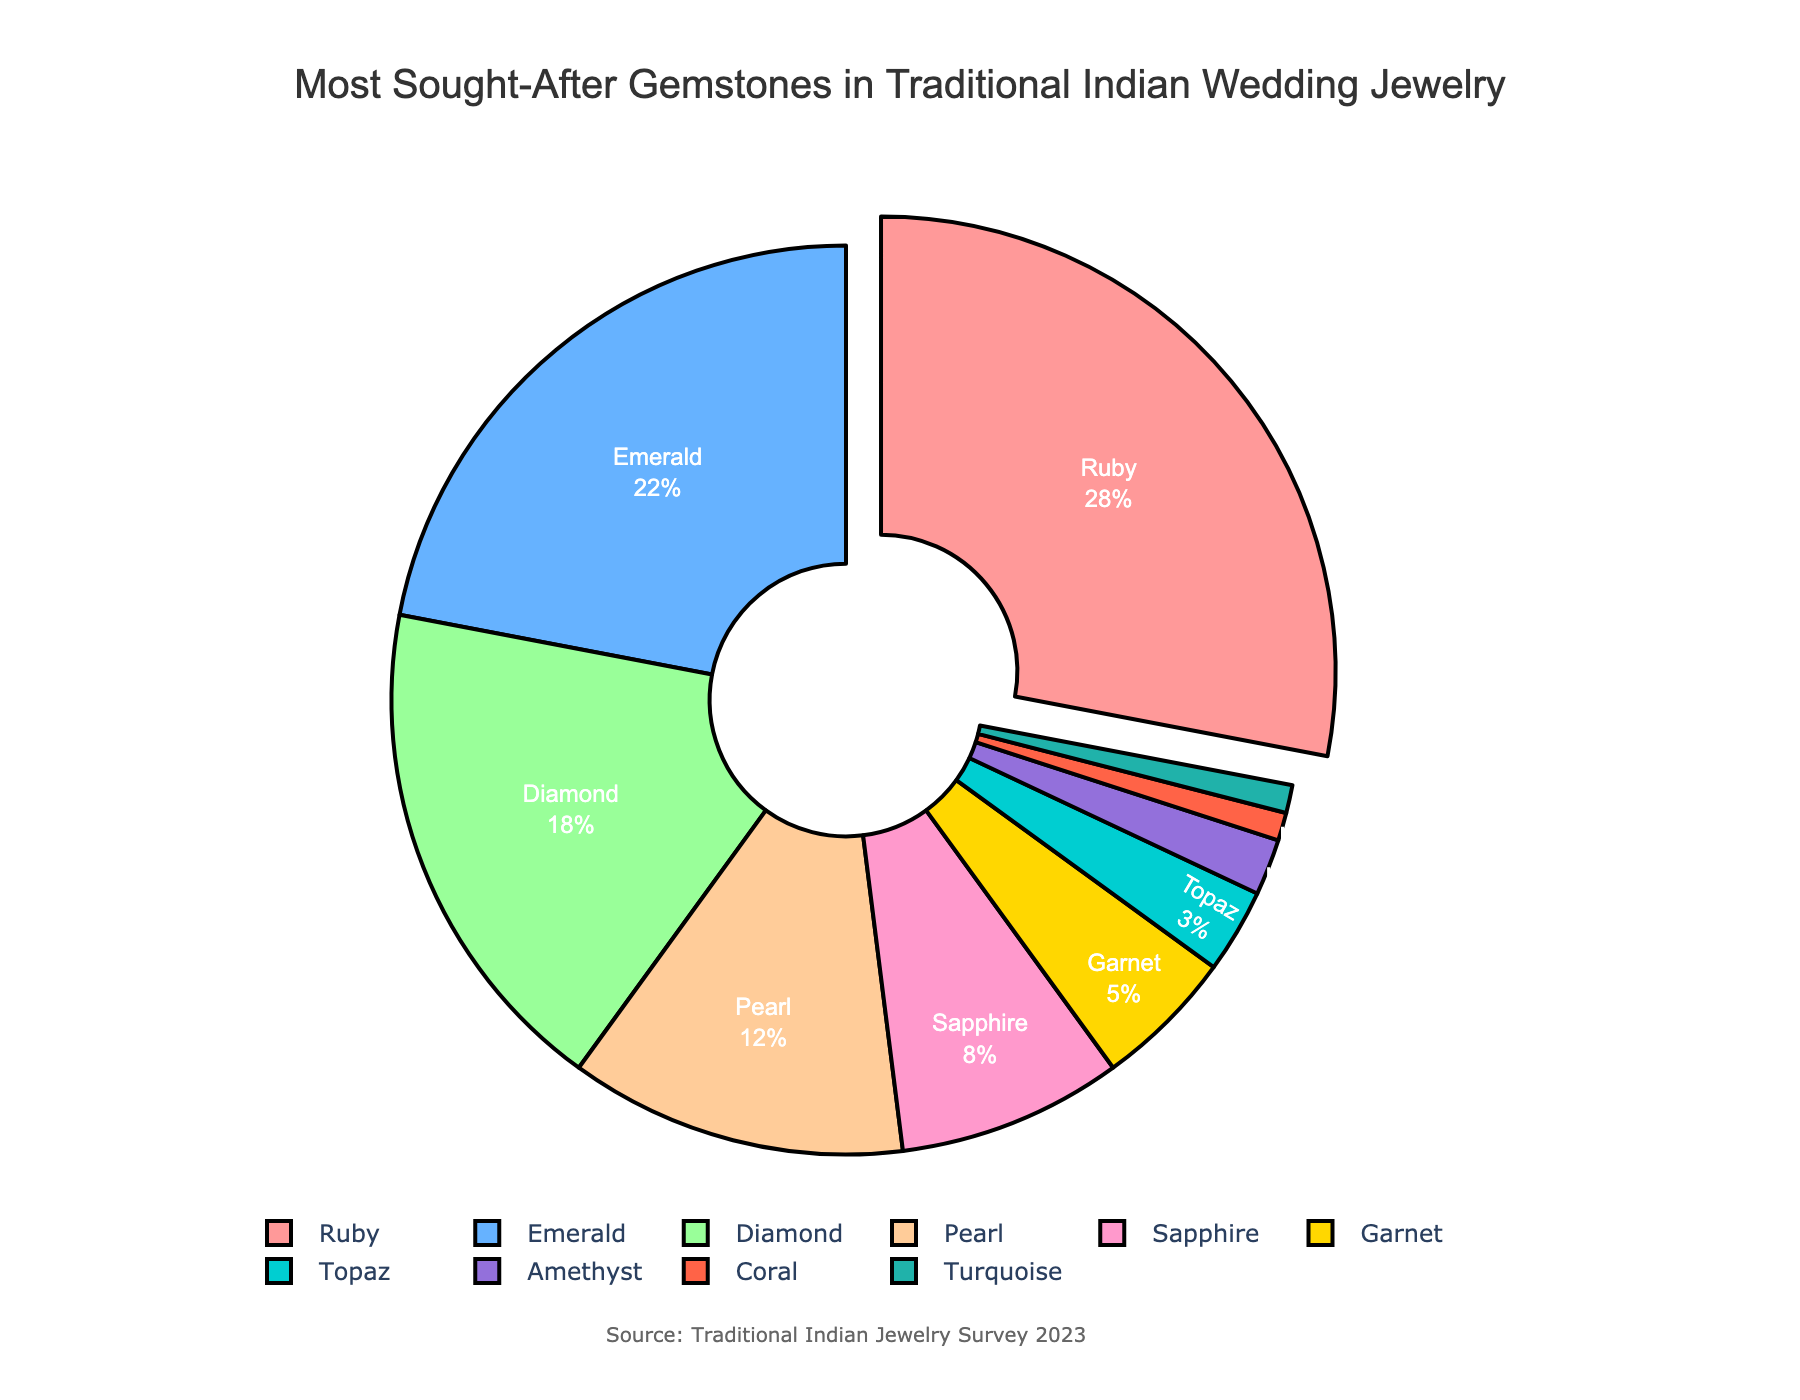What percentage of traditional Indian wedding jewelry uses Diamonds? To find the percentage of Diamonds, look at the pie chart and identify the segment labeled "Diamond". The text on the slice provides the percentage.
Answer: 18% Which gemstone is the most sought-after in traditional Indian wedding jewelry? The pie chart highlights the largest segment, which is labeled "Ruby". The largest segment represents the most sought-after gemstone.
Answer: Ruby How much more popular is Ruby than Sapphire in traditional Indian wedding jewelry? Find the percentages for Ruby and Sapphire in the pie chart. Ruby is 28% and Sapphire is 8%. Subtract the percentage for Sapphire from that of Ruby.
Answer: 20% Which gemstones are the least commonly used in traditional Indian wedding jewelry? Identify the smallest segments in the pie chart, which are labeled "Coral" and "Turquoise". Both have a minimal percentage.
Answer: Coral and Turquoise What is the total percentage of traditional Indian wedding jewelry that uses Ruby, Emerald, and Diamond combined? Sum the percentages for Ruby (28%), Emerald (22%), and Diamond (18%). 28 + 22 + 18 = 68.
Answer: 68% Compare the popularity between Emerald and Pearl gemstones. Which one is more popular and by how much? Find the percentages for Emerald and Pearl in the chart. Emerald is 22% and Pearl is 12%. Subtract Pearl's percentage from Emerald's.
Answer: Emerald by 10% If the three least popular gemstones are combined, what is their total percentage? Sum the percentages for Topaz (3%), Amethyst (2%), Coral (1%), and Turquoise (1%). 3 + 2 + 1 + 1 = 7.
Answer: 7% Which gemstones make up less than 10% of the traditional Indian wedding jewelry each? Identify all segments that have percentages less than 10%. These are Sapphire (8%), Garnet (5%), Topaz (3%), Amethyst (2%), Coral (1%), and Turquoise (1%).
Answer: Sapphire, Garnet, Topaz, Amethyst, Coral, and Turquoise What percentage of traditional Indian wedding jewelry uses gems other than Ruby, Emerald, and Diamond? Subtract the combined percentage of Ruby, Emerald, and Diamond (68%) from 100% to find the percentage of other gemstones. 100 - 68 = 32.
Answer: 32% How does the popularity of Sapphire compare to that of Pearl? Look at the percentages for Sapphire and Pearl. Sapphire is 8%, and Pearl is 12%. Pearl is more popular.
Answer: Pearl is more popular by 4% 